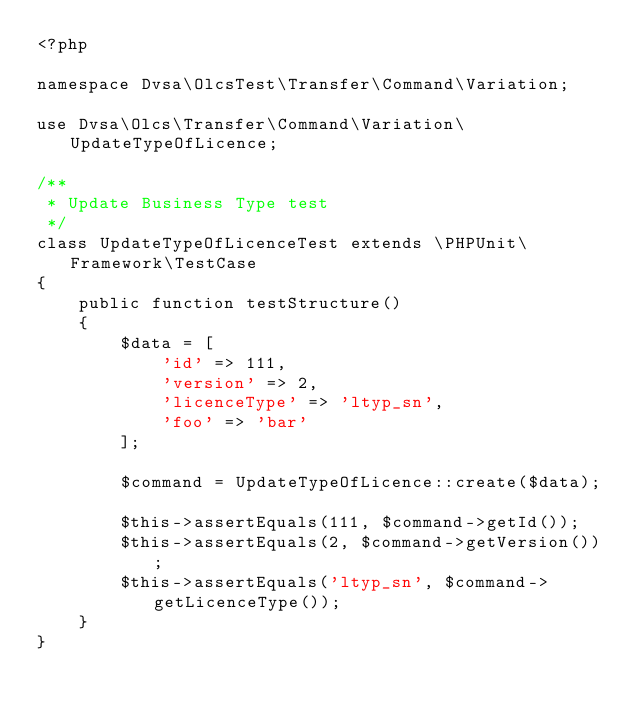<code> <loc_0><loc_0><loc_500><loc_500><_PHP_><?php

namespace Dvsa\OlcsTest\Transfer\Command\Variation;

use Dvsa\Olcs\Transfer\Command\Variation\UpdateTypeOfLicence;

/**
 * Update Business Type test
 */
class UpdateTypeOfLicenceTest extends \PHPUnit\Framework\TestCase
{
    public function testStructure()
    {
        $data = [
            'id' => 111,
            'version' => 2,
            'licenceType' => 'ltyp_sn',
            'foo' => 'bar'
        ];

        $command = UpdateTypeOfLicence::create($data);

        $this->assertEquals(111, $command->getId());
        $this->assertEquals(2, $command->getVersion());
        $this->assertEquals('ltyp_sn', $command->getLicenceType());
    }
}
</code> 